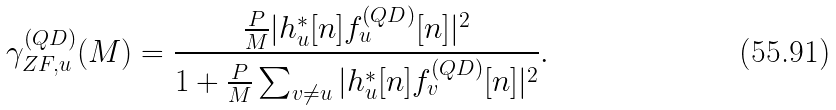Convert formula to latex. <formula><loc_0><loc_0><loc_500><loc_500>\gamma _ { Z F , u } ^ { ( Q D ) } ( M ) = \frac { \frac { P } { M } | h ^ { * } _ { u } [ n ] f ^ { ( Q D ) } _ { u } [ n ] | ^ { 2 } } { 1 + \frac { P } { M } \sum _ { v \neq { u } } | h _ { u } ^ { * } [ n ] f ^ { ( Q D ) } _ { v } [ n ] | ^ { 2 } } .</formula> 